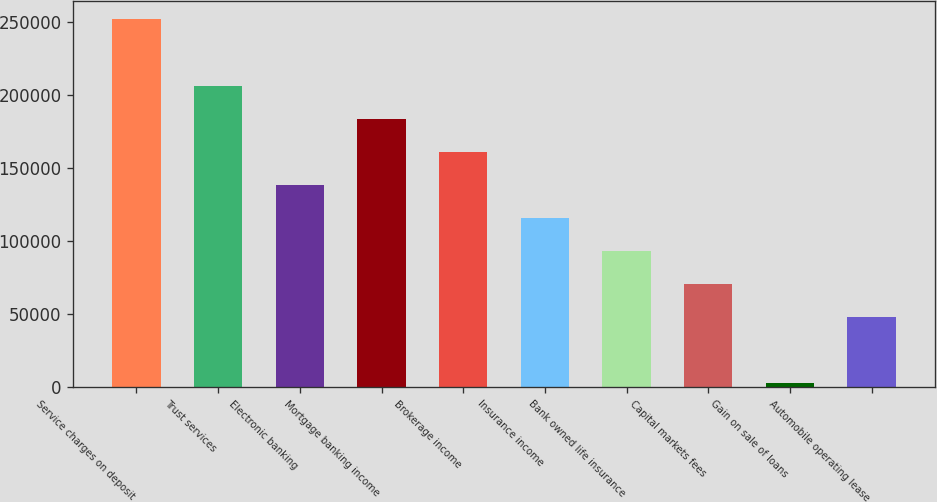Convert chart to OTSL. <chart><loc_0><loc_0><loc_500><loc_500><bar_chart><fcel>Service charges on deposit<fcel>Trust services<fcel>Electronic banking<fcel>Mortgage banking income<fcel>Brokerage income<fcel>Insurance income<fcel>Bank owned life insurance<fcel>Capital markets fees<fcel>Gain on sale of loans<fcel>Automobile operating lease<nl><fcel>251999<fcel>206705<fcel>138765<fcel>184058<fcel>161412<fcel>116118<fcel>93471.2<fcel>70824.4<fcel>2884<fcel>48177.6<nl></chart> 